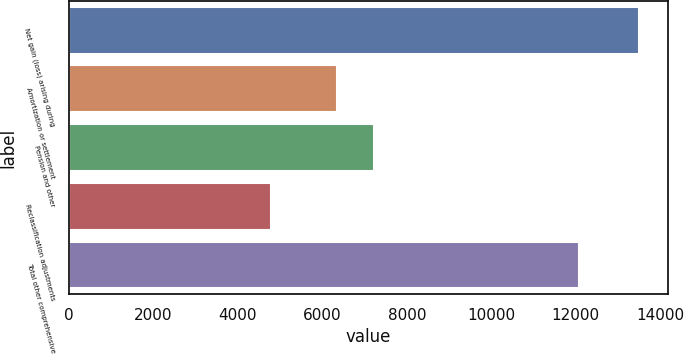<chart> <loc_0><loc_0><loc_500><loc_500><bar_chart><fcel>Net gain (loss) arising during<fcel>Amortization or settlement<fcel>Pension and other<fcel>Reclassification adjustments<fcel>Total other comprehensive<nl><fcel>13500<fcel>6341<fcel>7213<fcel>4780<fcel>12066<nl></chart> 